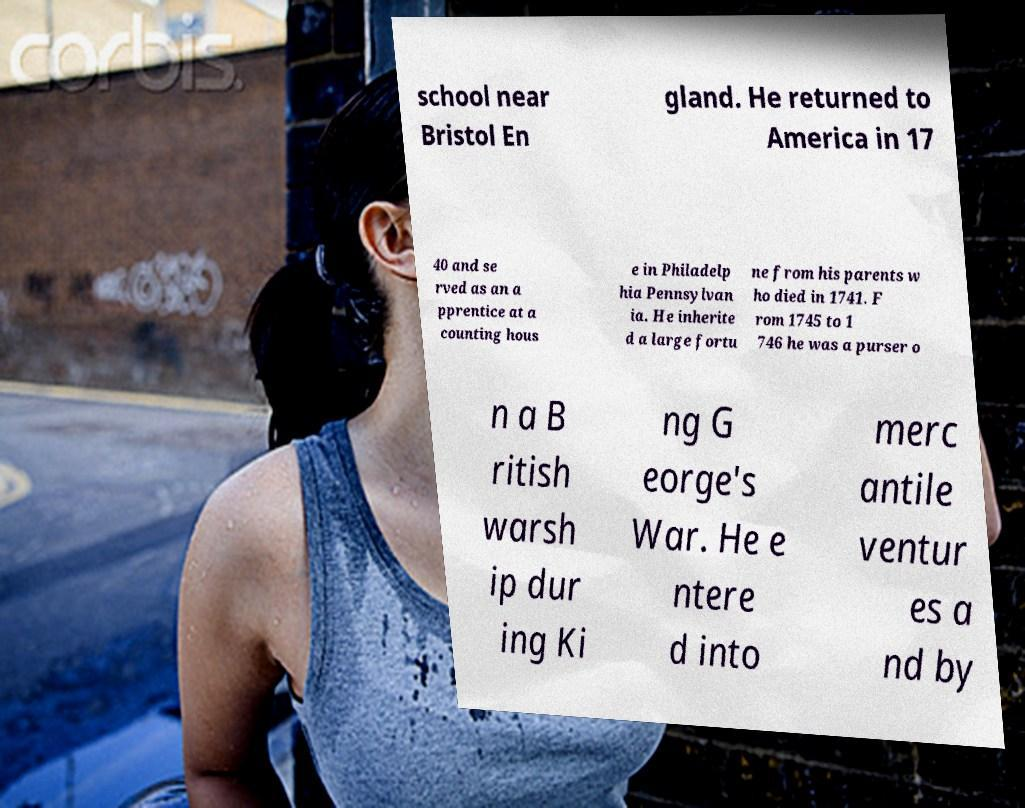What messages or text are displayed in this image? I need them in a readable, typed format. school near Bristol En gland. He returned to America in 17 40 and se rved as an a pprentice at a counting hous e in Philadelp hia Pennsylvan ia. He inherite d a large fortu ne from his parents w ho died in 1741. F rom 1745 to 1 746 he was a purser o n a B ritish warsh ip dur ing Ki ng G eorge's War. He e ntere d into merc antile ventur es a nd by 